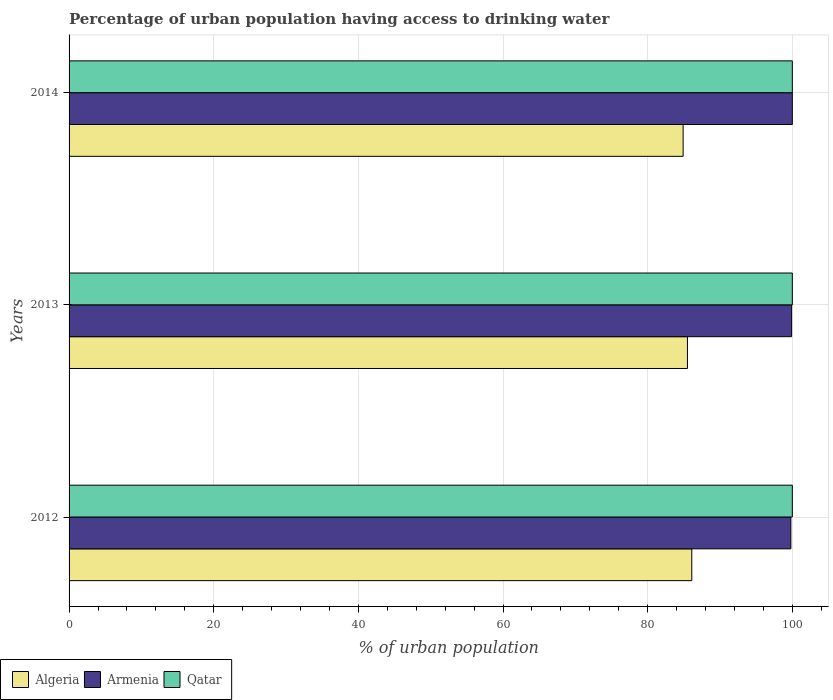How many groups of bars are there?
Provide a succinct answer. 3. Are the number of bars on each tick of the Y-axis equal?
Provide a short and direct response. Yes. In how many cases, is the number of bars for a given year not equal to the number of legend labels?
Offer a terse response. 0. What is the percentage of urban population having access to drinking water in Qatar in 2012?
Keep it short and to the point. 100. In which year was the percentage of urban population having access to drinking water in Algeria maximum?
Your answer should be very brief. 2012. What is the total percentage of urban population having access to drinking water in Armenia in the graph?
Your answer should be very brief. 299.7. What is the difference between the percentage of urban population having access to drinking water in Armenia in 2012 and that in 2013?
Ensure brevity in your answer.  -0.1. What is the difference between the percentage of urban population having access to drinking water in Algeria in 2014 and the percentage of urban population having access to drinking water in Qatar in 2012?
Your answer should be compact. -15.1. What is the average percentage of urban population having access to drinking water in Armenia per year?
Your answer should be compact. 99.9. In the year 2013, what is the difference between the percentage of urban population having access to drinking water in Armenia and percentage of urban population having access to drinking water in Algeria?
Provide a succinct answer. 14.4. What is the ratio of the percentage of urban population having access to drinking water in Armenia in 2013 to that in 2014?
Make the answer very short. 1. What is the difference between the highest and the lowest percentage of urban population having access to drinking water in Armenia?
Offer a very short reply. 0.2. In how many years, is the percentage of urban population having access to drinking water in Armenia greater than the average percentage of urban population having access to drinking water in Armenia taken over all years?
Ensure brevity in your answer.  2. Is the sum of the percentage of urban population having access to drinking water in Algeria in 2012 and 2014 greater than the maximum percentage of urban population having access to drinking water in Armenia across all years?
Your response must be concise. Yes. What does the 3rd bar from the top in 2013 represents?
Your response must be concise. Algeria. What does the 2nd bar from the bottom in 2012 represents?
Your answer should be compact. Armenia. How many bars are there?
Offer a terse response. 9. Are the values on the major ticks of X-axis written in scientific E-notation?
Ensure brevity in your answer.  No. Does the graph contain any zero values?
Offer a very short reply. No. Does the graph contain grids?
Keep it short and to the point. Yes. How are the legend labels stacked?
Provide a succinct answer. Horizontal. What is the title of the graph?
Ensure brevity in your answer.  Percentage of urban population having access to drinking water. Does "Qatar" appear as one of the legend labels in the graph?
Ensure brevity in your answer.  Yes. What is the label or title of the X-axis?
Your response must be concise. % of urban population. What is the % of urban population in Algeria in 2012?
Provide a short and direct response. 86.1. What is the % of urban population in Armenia in 2012?
Your response must be concise. 99.8. What is the % of urban population of Qatar in 2012?
Offer a terse response. 100. What is the % of urban population of Algeria in 2013?
Keep it short and to the point. 85.5. What is the % of urban population of Armenia in 2013?
Keep it short and to the point. 99.9. What is the % of urban population of Qatar in 2013?
Ensure brevity in your answer.  100. What is the % of urban population in Algeria in 2014?
Offer a very short reply. 84.9. What is the % of urban population of Armenia in 2014?
Provide a short and direct response. 100. Across all years, what is the maximum % of urban population in Algeria?
Your answer should be very brief. 86.1. Across all years, what is the maximum % of urban population of Armenia?
Offer a terse response. 100. Across all years, what is the maximum % of urban population in Qatar?
Your answer should be very brief. 100. Across all years, what is the minimum % of urban population of Algeria?
Provide a succinct answer. 84.9. Across all years, what is the minimum % of urban population in Armenia?
Keep it short and to the point. 99.8. Across all years, what is the minimum % of urban population in Qatar?
Provide a short and direct response. 100. What is the total % of urban population in Algeria in the graph?
Make the answer very short. 256.5. What is the total % of urban population of Armenia in the graph?
Your answer should be compact. 299.7. What is the total % of urban population in Qatar in the graph?
Offer a very short reply. 300. What is the difference between the % of urban population of Algeria in 2012 and that in 2013?
Ensure brevity in your answer.  0.6. What is the difference between the % of urban population in Algeria in 2012 and that in 2014?
Your answer should be very brief. 1.2. What is the difference between the % of urban population of Algeria in 2012 and the % of urban population of Qatar in 2013?
Offer a very short reply. -13.9. What is the difference between the % of urban population of Armenia in 2012 and the % of urban population of Qatar in 2013?
Offer a very short reply. -0.2. What is the difference between the % of urban population of Algeria in 2012 and the % of urban population of Armenia in 2014?
Give a very brief answer. -13.9. What is the difference between the % of urban population in Algeria in 2012 and the % of urban population in Qatar in 2014?
Your answer should be very brief. -13.9. What is the average % of urban population in Algeria per year?
Keep it short and to the point. 85.5. What is the average % of urban population in Armenia per year?
Provide a succinct answer. 99.9. In the year 2012, what is the difference between the % of urban population of Algeria and % of urban population of Armenia?
Your answer should be very brief. -13.7. In the year 2012, what is the difference between the % of urban population of Algeria and % of urban population of Qatar?
Keep it short and to the point. -13.9. In the year 2012, what is the difference between the % of urban population in Armenia and % of urban population in Qatar?
Your answer should be compact. -0.2. In the year 2013, what is the difference between the % of urban population of Algeria and % of urban population of Armenia?
Give a very brief answer. -14.4. In the year 2014, what is the difference between the % of urban population of Algeria and % of urban population of Armenia?
Offer a very short reply. -15.1. In the year 2014, what is the difference between the % of urban population of Algeria and % of urban population of Qatar?
Keep it short and to the point. -15.1. In the year 2014, what is the difference between the % of urban population in Armenia and % of urban population in Qatar?
Your response must be concise. 0. What is the ratio of the % of urban population of Qatar in 2012 to that in 2013?
Provide a succinct answer. 1. What is the ratio of the % of urban population in Algeria in 2012 to that in 2014?
Make the answer very short. 1.01. What is the ratio of the % of urban population in Armenia in 2012 to that in 2014?
Make the answer very short. 1. What is the ratio of the % of urban population of Algeria in 2013 to that in 2014?
Provide a succinct answer. 1.01. What is the ratio of the % of urban population in Qatar in 2013 to that in 2014?
Ensure brevity in your answer.  1. What is the difference between the highest and the second highest % of urban population of Algeria?
Your answer should be very brief. 0.6. What is the difference between the highest and the lowest % of urban population of Armenia?
Your answer should be very brief. 0.2. What is the difference between the highest and the lowest % of urban population of Qatar?
Provide a succinct answer. 0. 